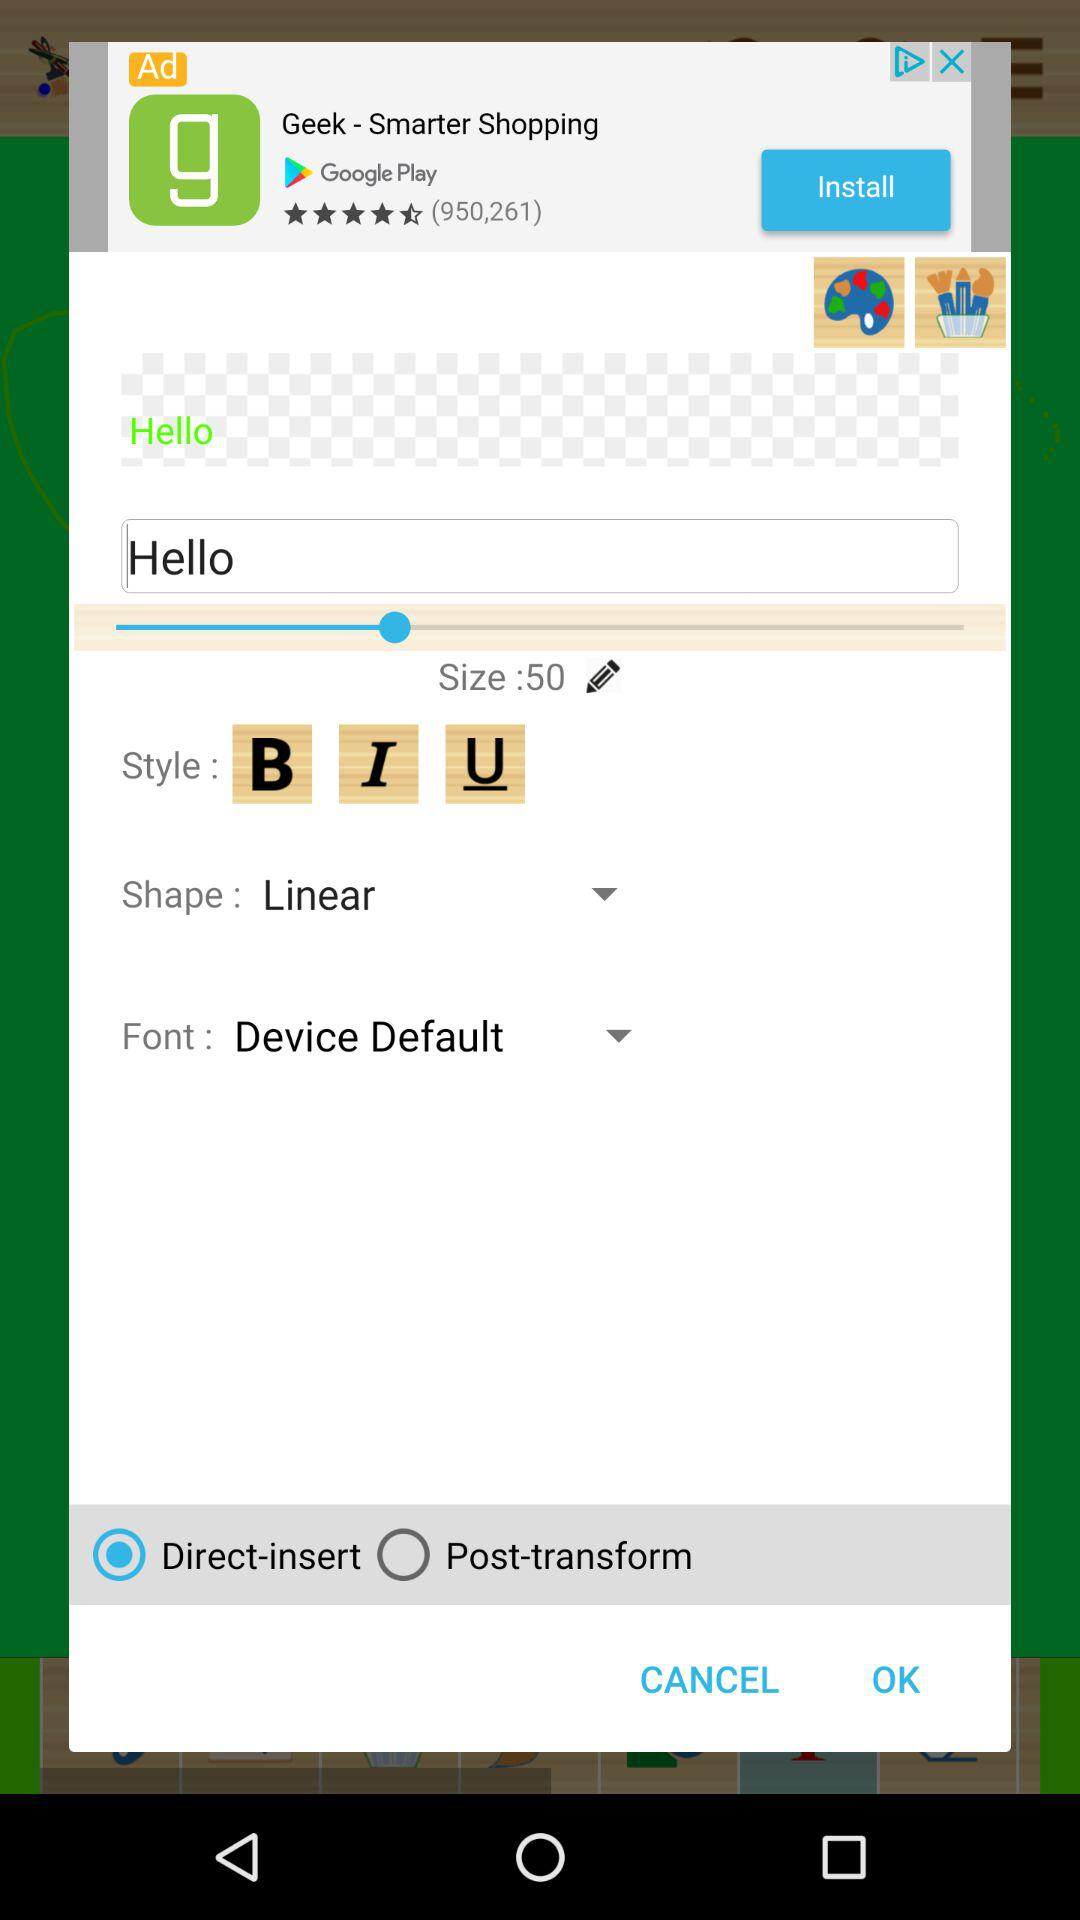What is the style for text? The style for text is bold, italic and underline. 